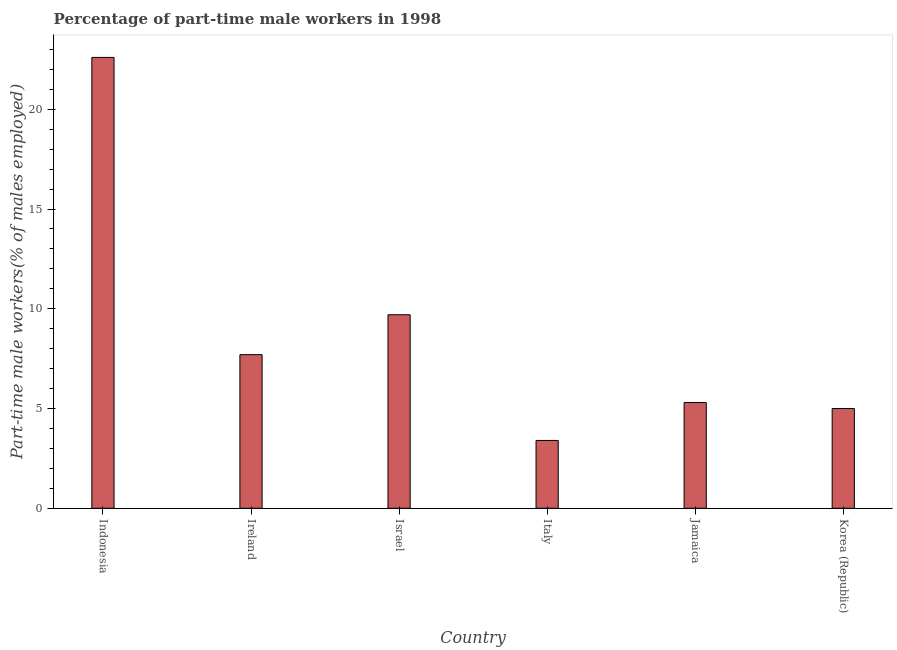What is the title of the graph?
Provide a short and direct response. Percentage of part-time male workers in 1998. What is the label or title of the Y-axis?
Your response must be concise. Part-time male workers(% of males employed). What is the percentage of part-time male workers in Ireland?
Offer a terse response. 7.7. Across all countries, what is the maximum percentage of part-time male workers?
Provide a short and direct response. 22.6. Across all countries, what is the minimum percentage of part-time male workers?
Provide a short and direct response. 3.4. In which country was the percentage of part-time male workers maximum?
Keep it short and to the point. Indonesia. What is the sum of the percentage of part-time male workers?
Offer a very short reply. 53.7. What is the average percentage of part-time male workers per country?
Your response must be concise. 8.95. What is the median percentage of part-time male workers?
Keep it short and to the point. 6.5. What is the ratio of the percentage of part-time male workers in Jamaica to that in Korea (Republic)?
Give a very brief answer. 1.06. Is the percentage of part-time male workers in Indonesia less than that in Korea (Republic)?
Keep it short and to the point. No. Is the difference between the percentage of part-time male workers in Ireland and Israel greater than the difference between any two countries?
Offer a terse response. No. What is the difference between the highest and the second highest percentage of part-time male workers?
Provide a short and direct response. 12.9. Is the sum of the percentage of part-time male workers in Indonesia and Israel greater than the maximum percentage of part-time male workers across all countries?
Your answer should be very brief. Yes. What is the difference between the highest and the lowest percentage of part-time male workers?
Give a very brief answer. 19.2. In how many countries, is the percentage of part-time male workers greater than the average percentage of part-time male workers taken over all countries?
Provide a short and direct response. 2. How many bars are there?
Offer a very short reply. 6. How many countries are there in the graph?
Provide a short and direct response. 6. What is the difference between two consecutive major ticks on the Y-axis?
Keep it short and to the point. 5. What is the Part-time male workers(% of males employed) in Indonesia?
Offer a very short reply. 22.6. What is the Part-time male workers(% of males employed) in Ireland?
Offer a terse response. 7.7. What is the Part-time male workers(% of males employed) in Israel?
Provide a succinct answer. 9.7. What is the Part-time male workers(% of males employed) of Italy?
Keep it short and to the point. 3.4. What is the Part-time male workers(% of males employed) in Jamaica?
Provide a short and direct response. 5.3. What is the difference between the Part-time male workers(% of males employed) in Indonesia and Israel?
Make the answer very short. 12.9. What is the difference between the Part-time male workers(% of males employed) in Indonesia and Jamaica?
Ensure brevity in your answer.  17.3. What is the difference between the Part-time male workers(% of males employed) in Ireland and Italy?
Make the answer very short. 4.3. What is the difference between the Part-time male workers(% of males employed) in Ireland and Korea (Republic)?
Provide a succinct answer. 2.7. What is the difference between the Part-time male workers(% of males employed) in Israel and Korea (Republic)?
Your response must be concise. 4.7. What is the difference between the Part-time male workers(% of males employed) in Italy and Korea (Republic)?
Your response must be concise. -1.6. What is the difference between the Part-time male workers(% of males employed) in Jamaica and Korea (Republic)?
Make the answer very short. 0.3. What is the ratio of the Part-time male workers(% of males employed) in Indonesia to that in Ireland?
Keep it short and to the point. 2.94. What is the ratio of the Part-time male workers(% of males employed) in Indonesia to that in Israel?
Provide a short and direct response. 2.33. What is the ratio of the Part-time male workers(% of males employed) in Indonesia to that in Italy?
Provide a succinct answer. 6.65. What is the ratio of the Part-time male workers(% of males employed) in Indonesia to that in Jamaica?
Provide a succinct answer. 4.26. What is the ratio of the Part-time male workers(% of males employed) in Indonesia to that in Korea (Republic)?
Keep it short and to the point. 4.52. What is the ratio of the Part-time male workers(% of males employed) in Ireland to that in Israel?
Your answer should be compact. 0.79. What is the ratio of the Part-time male workers(% of males employed) in Ireland to that in Italy?
Provide a short and direct response. 2.27. What is the ratio of the Part-time male workers(% of males employed) in Ireland to that in Jamaica?
Give a very brief answer. 1.45. What is the ratio of the Part-time male workers(% of males employed) in Ireland to that in Korea (Republic)?
Your answer should be compact. 1.54. What is the ratio of the Part-time male workers(% of males employed) in Israel to that in Italy?
Offer a terse response. 2.85. What is the ratio of the Part-time male workers(% of males employed) in Israel to that in Jamaica?
Your answer should be compact. 1.83. What is the ratio of the Part-time male workers(% of males employed) in Israel to that in Korea (Republic)?
Ensure brevity in your answer.  1.94. What is the ratio of the Part-time male workers(% of males employed) in Italy to that in Jamaica?
Make the answer very short. 0.64. What is the ratio of the Part-time male workers(% of males employed) in Italy to that in Korea (Republic)?
Provide a succinct answer. 0.68. What is the ratio of the Part-time male workers(% of males employed) in Jamaica to that in Korea (Republic)?
Offer a very short reply. 1.06. 